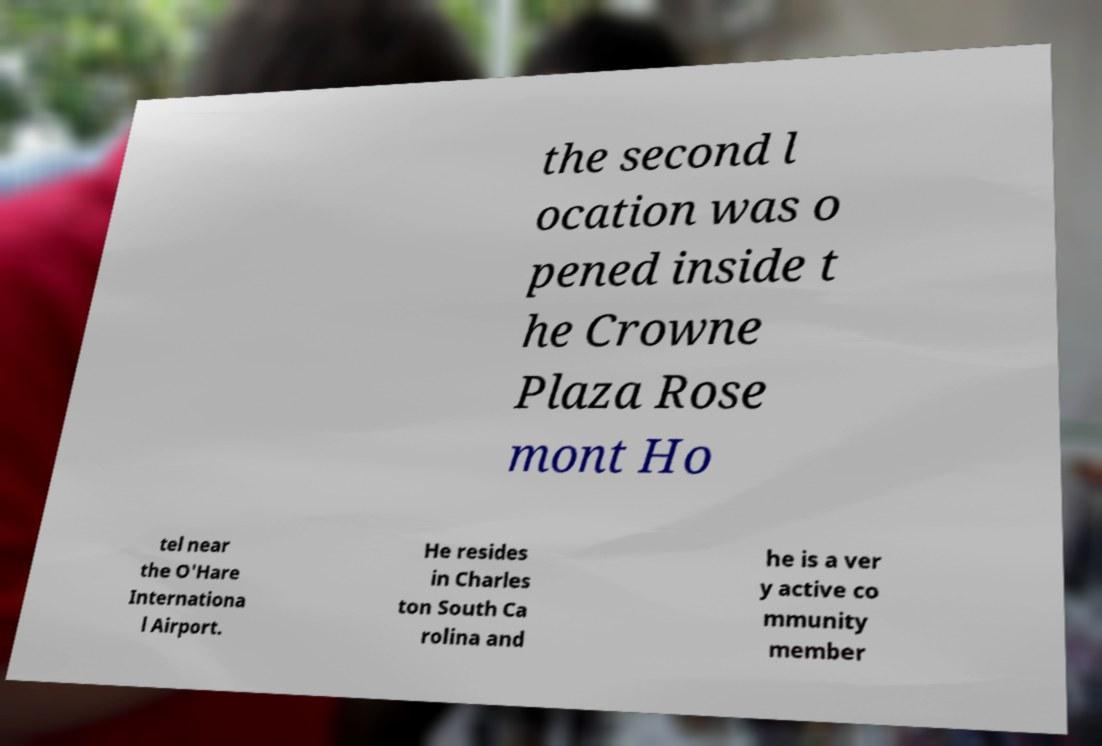Could you extract and type out the text from this image? the second l ocation was o pened inside t he Crowne Plaza Rose mont Ho tel near the O'Hare Internationa l Airport. He resides in Charles ton South Ca rolina and he is a ver y active co mmunity member 